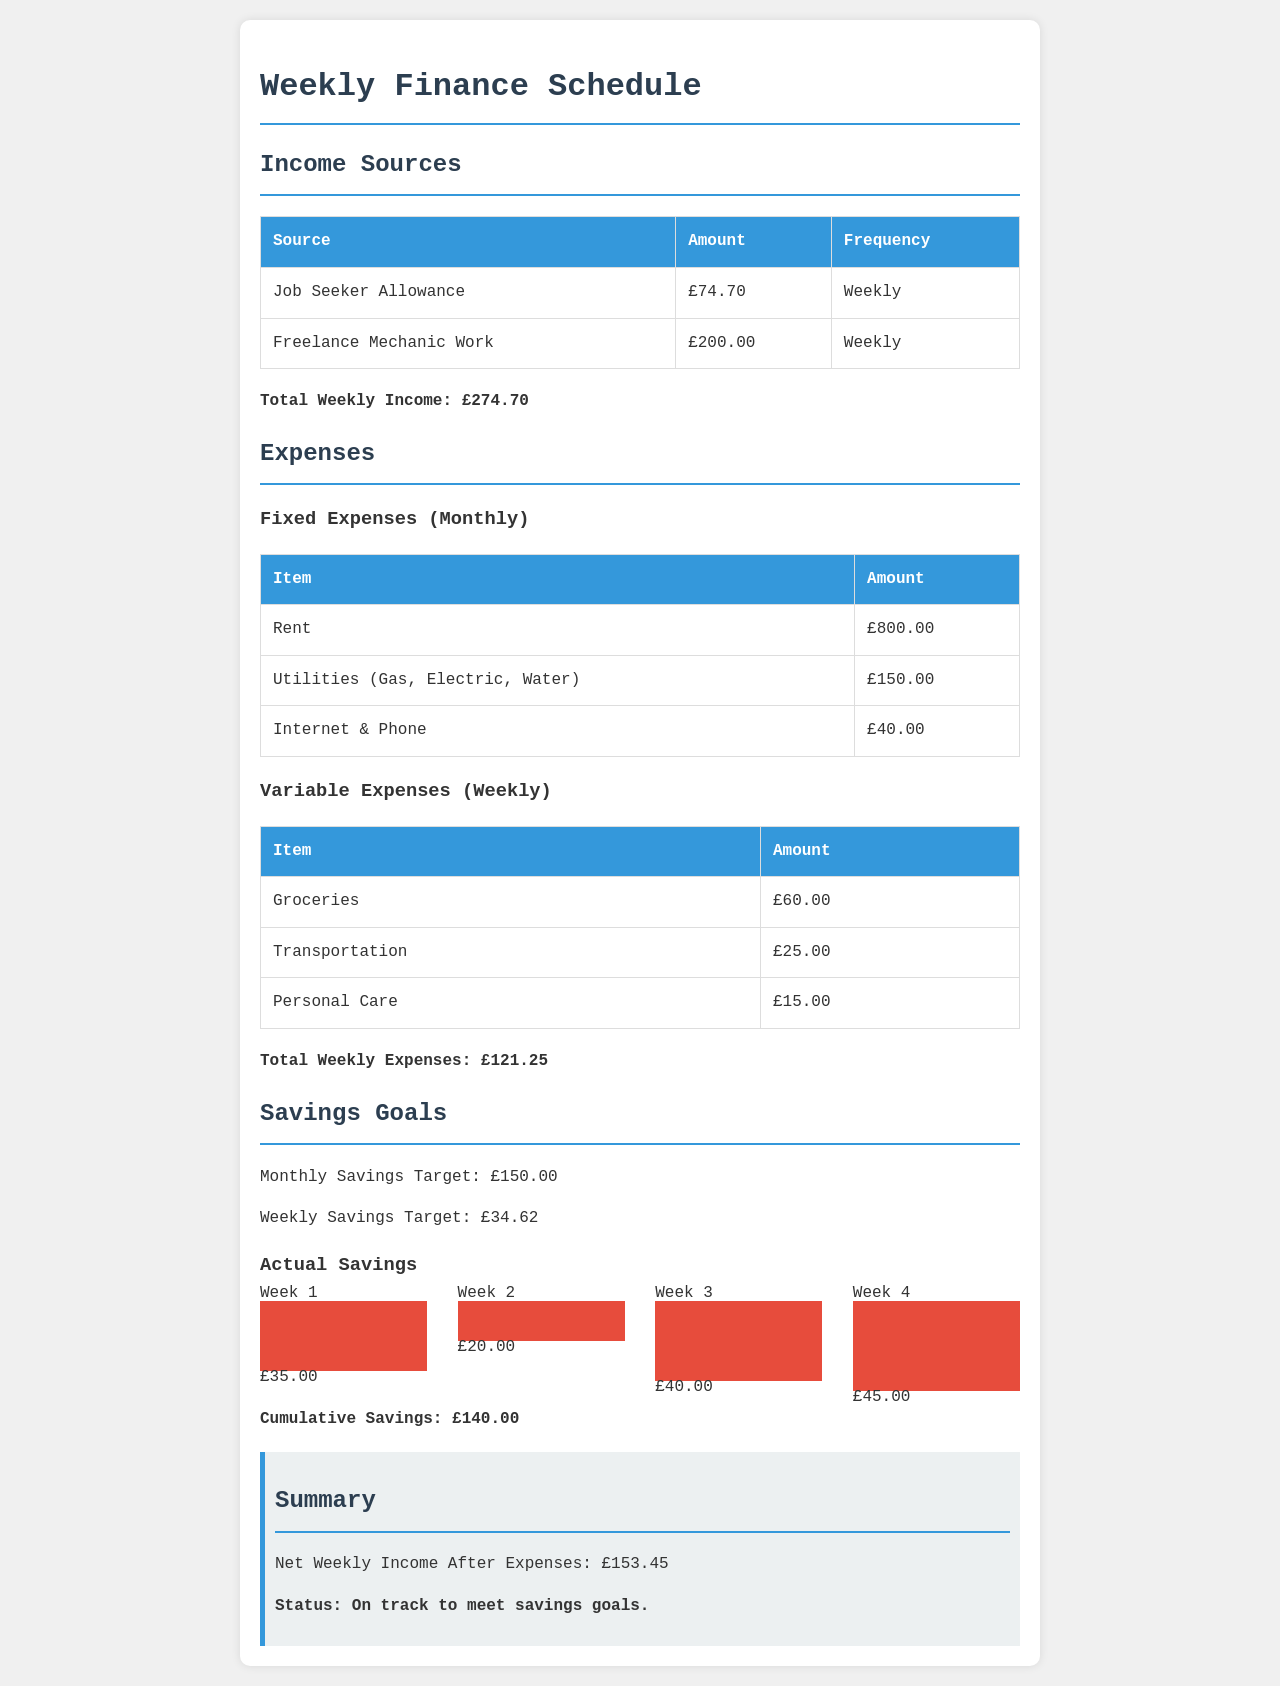What is the total weekly income? The total weekly income is displayed at the end of the income section, which adds up to £274.70.
Answer: £274.70 How much is spent on groceries weekly? The weekly expenses section lists groceries with an amount of £60.00.
Answer: £60.00 What is the cumulative savings amount? The cumulative savings total is provided at the end of the savings goals section, which states £140.00.
Answer: £140.00 What is the weekly savings target? The document mentions a weekly savings target of £34.62 in the savings goals section.
Answer: £34.62 What is the net weekly income after expenses? The net weekly income after expenses is stated in the summary section as £153.45.
Answer: £153.45 How many weeks worth of savings data is provided? The savings chart displays data for four weeks, indicating a total of four weeks' worth of savings.
Answer: Four weeks What is the total amount spent on transportation weekly? Transportation expenses in the variable expenses section shows £25.00 is spent weekly.
Answer: £25.00 What was the savings in Week 3? The savings chart indicates that £40.00 was saved in Week 3, shown in the respective bar.
Answer: £40.00 What is the total fixed expenses amount for rent, utilities, and internet monthly? Adding the monthly fixed expenses of rent (£800.00), utilities (£150.00), and internet (£40.00) totals to £990.00.
Answer: £990.00 